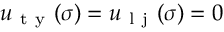Convert formula to latex. <formula><loc_0><loc_0><loc_500><loc_500>u _ { t y } ( \sigma ) = u _ { l j } ( \sigma ) = 0</formula> 